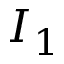Convert formula to latex. <formula><loc_0><loc_0><loc_500><loc_500>I _ { 1 }</formula> 